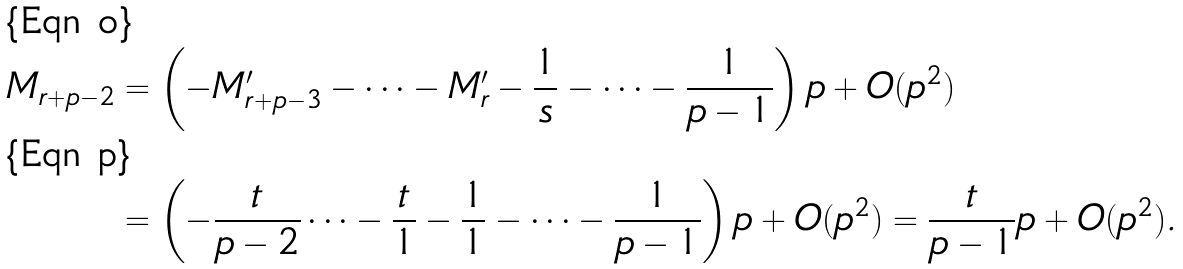<formula> <loc_0><loc_0><loc_500><loc_500>M _ { r + p - 2 } & = \left ( - M _ { r + p - 3 } ^ { \prime } - \cdots - M _ { r } ^ { \prime } - \frac { 1 } { s } - \cdots - \frac { 1 } { p - 1 } \right ) p + O ( p ^ { 2 } ) \\ & = \left ( - \frac { t } { p - 2 } \cdots - \frac { t } { 1 } - \frac { 1 } { 1 } - \cdots - \frac { 1 } { p - 1 } \right ) p + O ( p ^ { 2 } ) = \frac { t } { p - 1 } p + O ( p ^ { 2 } ) .</formula> 